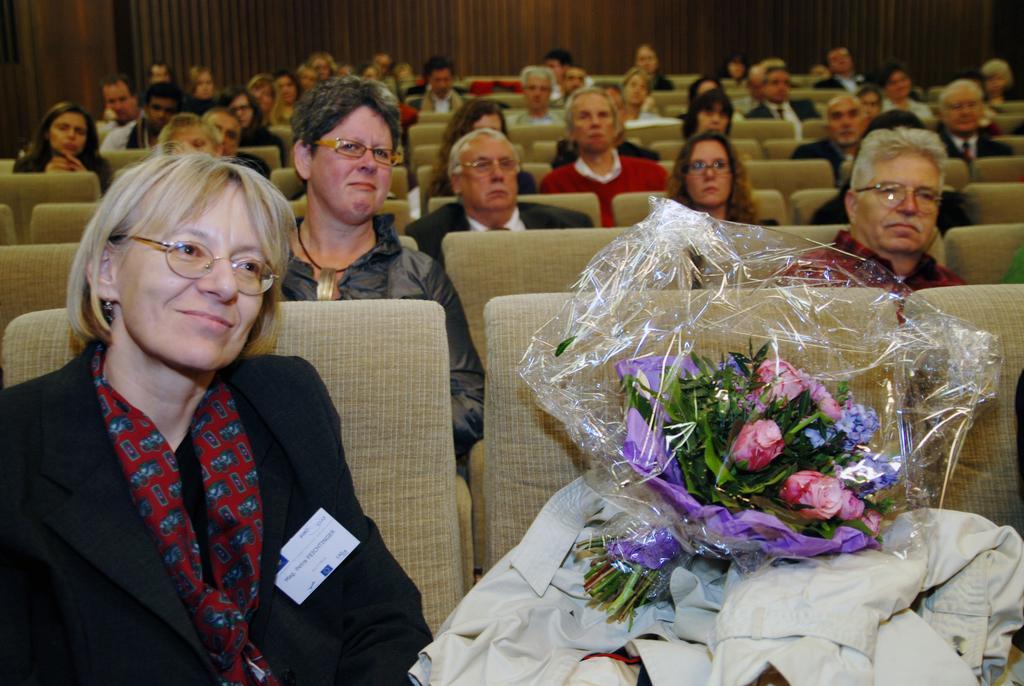Can you describe this image briefly? In this picture we see a group of men and women sitting on the auditorium chairs and looking straight. In the front we can see a woman wearing black coat, sitting and smiling. Beside there is a flower bouquet and a white jacket. 